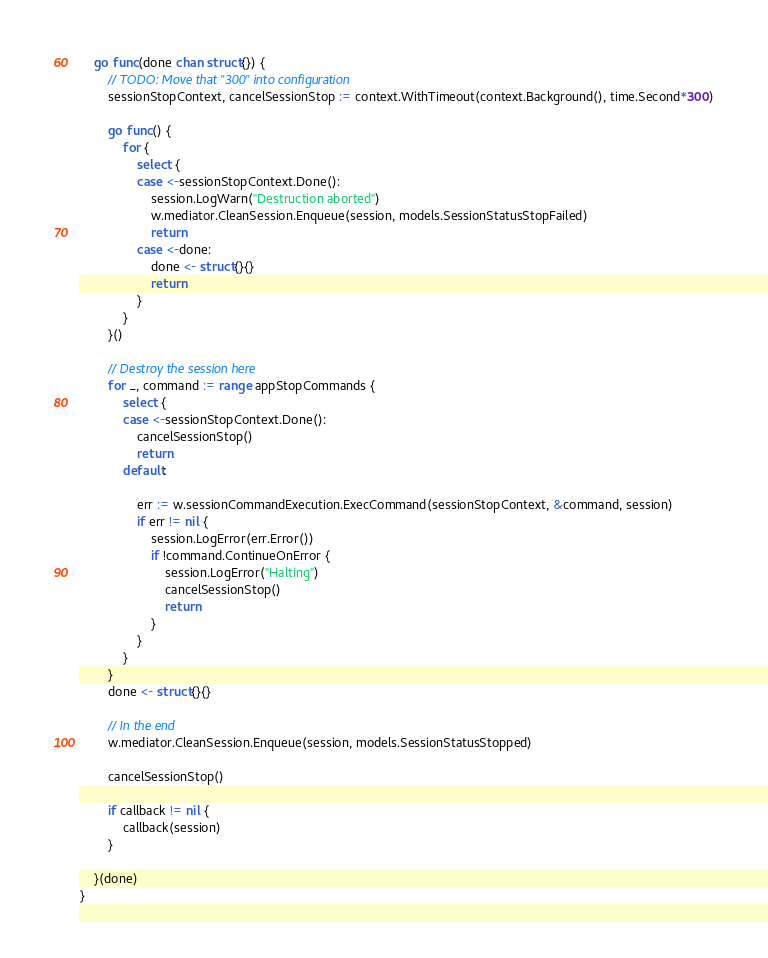Convert code to text. <code><loc_0><loc_0><loc_500><loc_500><_Go_>
	go func(done chan struct{}) {
		// TODO: Move that "300" into configuration
		sessionStopContext, cancelSessionStop := context.WithTimeout(context.Background(), time.Second*300)

		go func() {
			for {
				select {
				case <-sessionStopContext.Done():
					session.LogWarn("Destruction aborted")
					w.mediator.CleanSession.Enqueue(session, models.SessionStatusStopFailed)
					return
				case <-done:
					done <- struct{}{}
					return
				}
			}
		}()

		// Destroy the session here
		for _, command := range appStopCommands {
			select {
			case <-sessionStopContext.Done():
				cancelSessionStop()
				return
			default:

				err := w.sessionCommandExecution.ExecCommand(sessionStopContext, &command, session)
				if err != nil {
					session.LogError(err.Error())
					if !command.ContinueOnError {
						session.LogError("Halting")
						cancelSessionStop()
						return
					}
				}
			}
		}
		done <- struct{}{}

		// In the end
		w.mediator.CleanSession.Enqueue(session, models.SessionStatusStopped)

		cancelSessionStop()

		if callback != nil {
			callback(session)
		}

	}(done)
}
</code> 